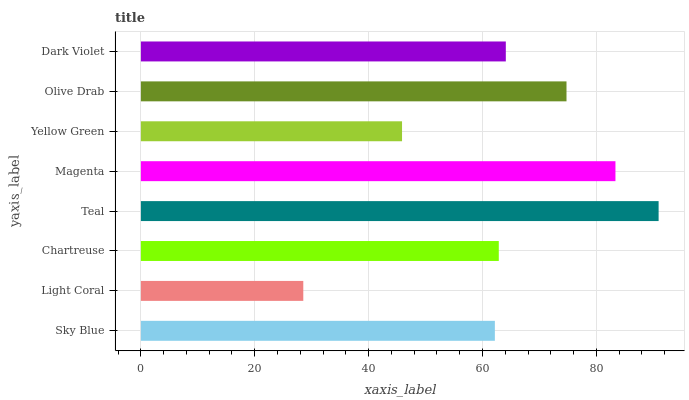Is Light Coral the minimum?
Answer yes or no. Yes. Is Teal the maximum?
Answer yes or no. Yes. Is Chartreuse the minimum?
Answer yes or no. No. Is Chartreuse the maximum?
Answer yes or no. No. Is Chartreuse greater than Light Coral?
Answer yes or no. Yes. Is Light Coral less than Chartreuse?
Answer yes or no. Yes. Is Light Coral greater than Chartreuse?
Answer yes or no. No. Is Chartreuse less than Light Coral?
Answer yes or no. No. Is Dark Violet the high median?
Answer yes or no. Yes. Is Chartreuse the low median?
Answer yes or no. Yes. Is Olive Drab the high median?
Answer yes or no. No. Is Dark Violet the low median?
Answer yes or no. No. 